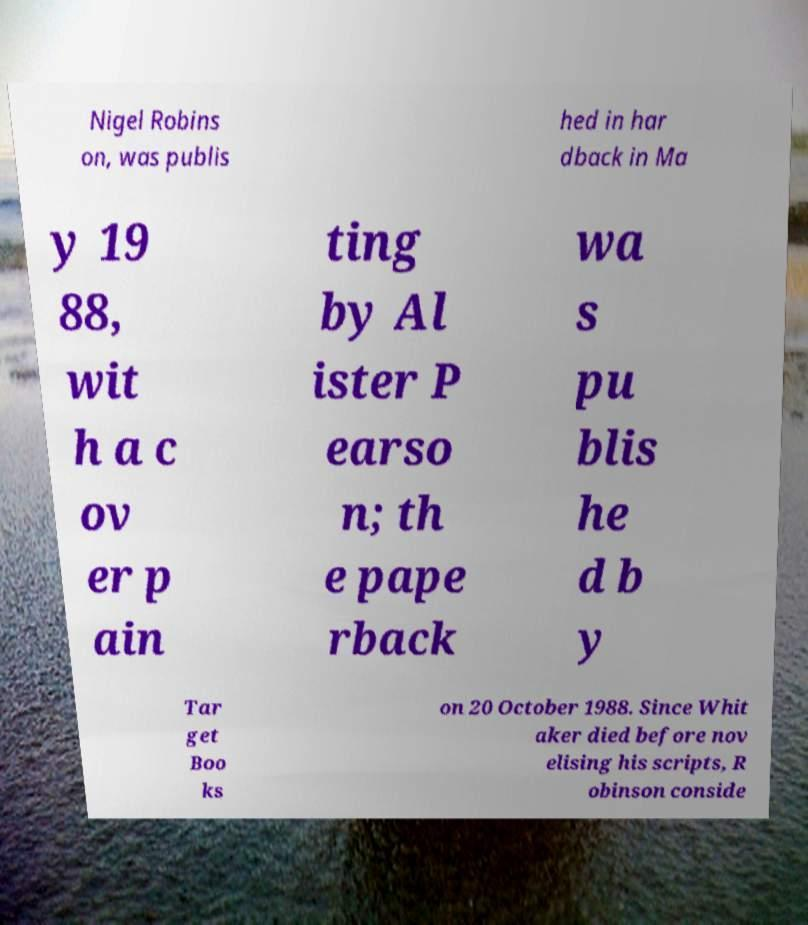What messages or text are displayed in this image? I need them in a readable, typed format. Nigel Robins on, was publis hed in har dback in Ma y 19 88, wit h a c ov er p ain ting by Al ister P earso n; th e pape rback wa s pu blis he d b y Tar get Boo ks on 20 October 1988. Since Whit aker died before nov elising his scripts, R obinson conside 